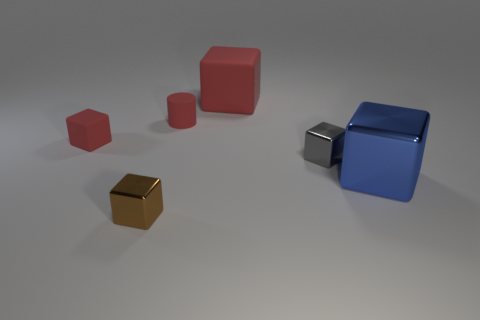What does the arrangement of these shapes tell us about their potential use in a learning environment? The varying sizes and colors of the shapes suggest that they could be used as educational tools to teach concepts such as geometry, proportion, comparative size, and color recognition, likely targeting younger learners. 